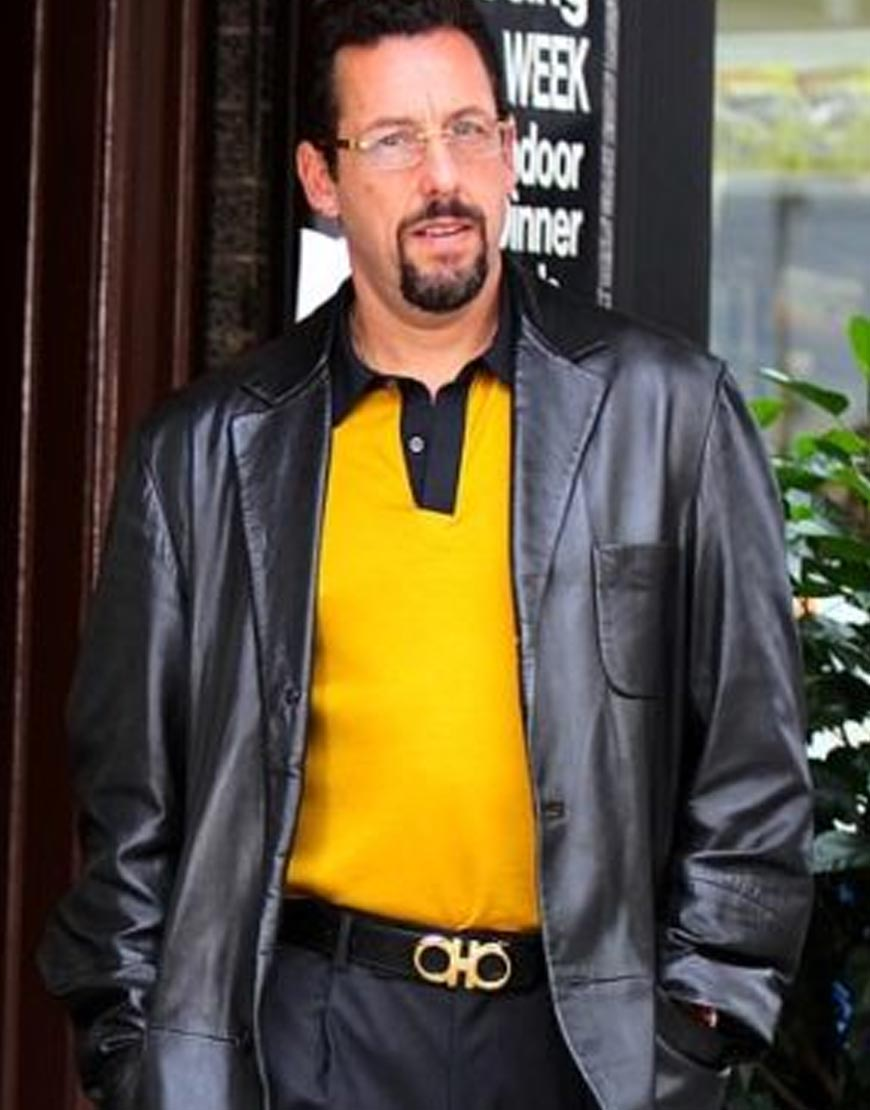Imagine a creative scenario involving the man in the image. Imagine this man is not just any ordinary person, but a covert secret agent on a mission to retrieve a vital piece of information hidden in this very location. He is disguised as an upscale businessman to blend into the surroundings. The black leather jacket conceals various high-tech gadgets. With each step, he glances around observantly, ensuring he remains unnoticed. Just as he moves closer to the target, his watch beeps softly—a signal from headquarters. The next few minutes will determine the success of his mission and the fate of millions. The tension is palpable, and every second counts. 